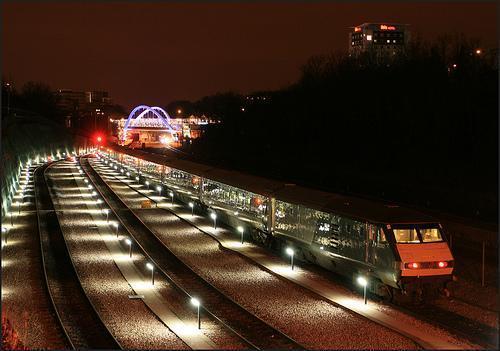How many tracks are shown?
Give a very brief answer. 3. 